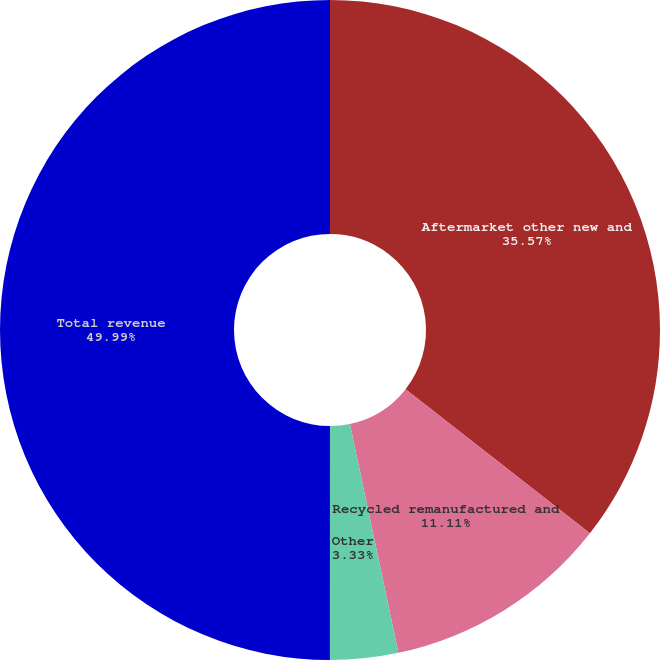<chart> <loc_0><loc_0><loc_500><loc_500><pie_chart><fcel>Aftermarket other new and<fcel>Recycled remanufactured and<fcel>Other<fcel>Total revenue<nl><fcel>35.57%<fcel>11.11%<fcel>3.33%<fcel>50.0%<nl></chart> 